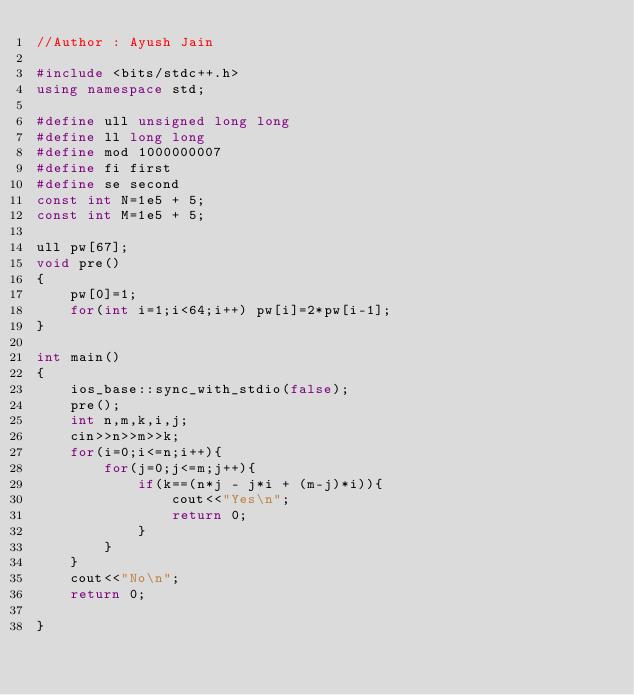Convert code to text. <code><loc_0><loc_0><loc_500><loc_500><_C++_>//Author : Ayush Jain

#include <bits/stdc++.h>
using namespace std;

#define ull unsigned long long
#define ll long long
#define mod 1000000007
#define fi first
#define se second
const int N=1e5 + 5;
const int M=1e5 + 5;

ull pw[67];
void pre()
{
	pw[0]=1;
	for(int i=1;i<64;i++) pw[i]=2*pw[i-1];
}

int main()
{
	ios_base::sync_with_stdio(false);
	pre();
	int n,m,k,i,j;
	cin>>n>>m>>k;	
	for(i=0;i<=n;i++){
		for(j=0;j<=m;j++){
			if(k==(n*j - j*i + (m-j)*i)){
				cout<<"Yes\n";
				return 0;
			}
		}
	}	
	cout<<"No\n";
	return 0;
	
}</code> 